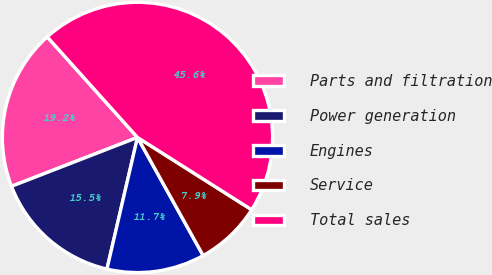<chart> <loc_0><loc_0><loc_500><loc_500><pie_chart><fcel>Parts and filtration<fcel>Power generation<fcel>Engines<fcel>Service<fcel>Total sales<nl><fcel>19.25%<fcel>15.48%<fcel>11.71%<fcel>7.94%<fcel>45.63%<nl></chart> 